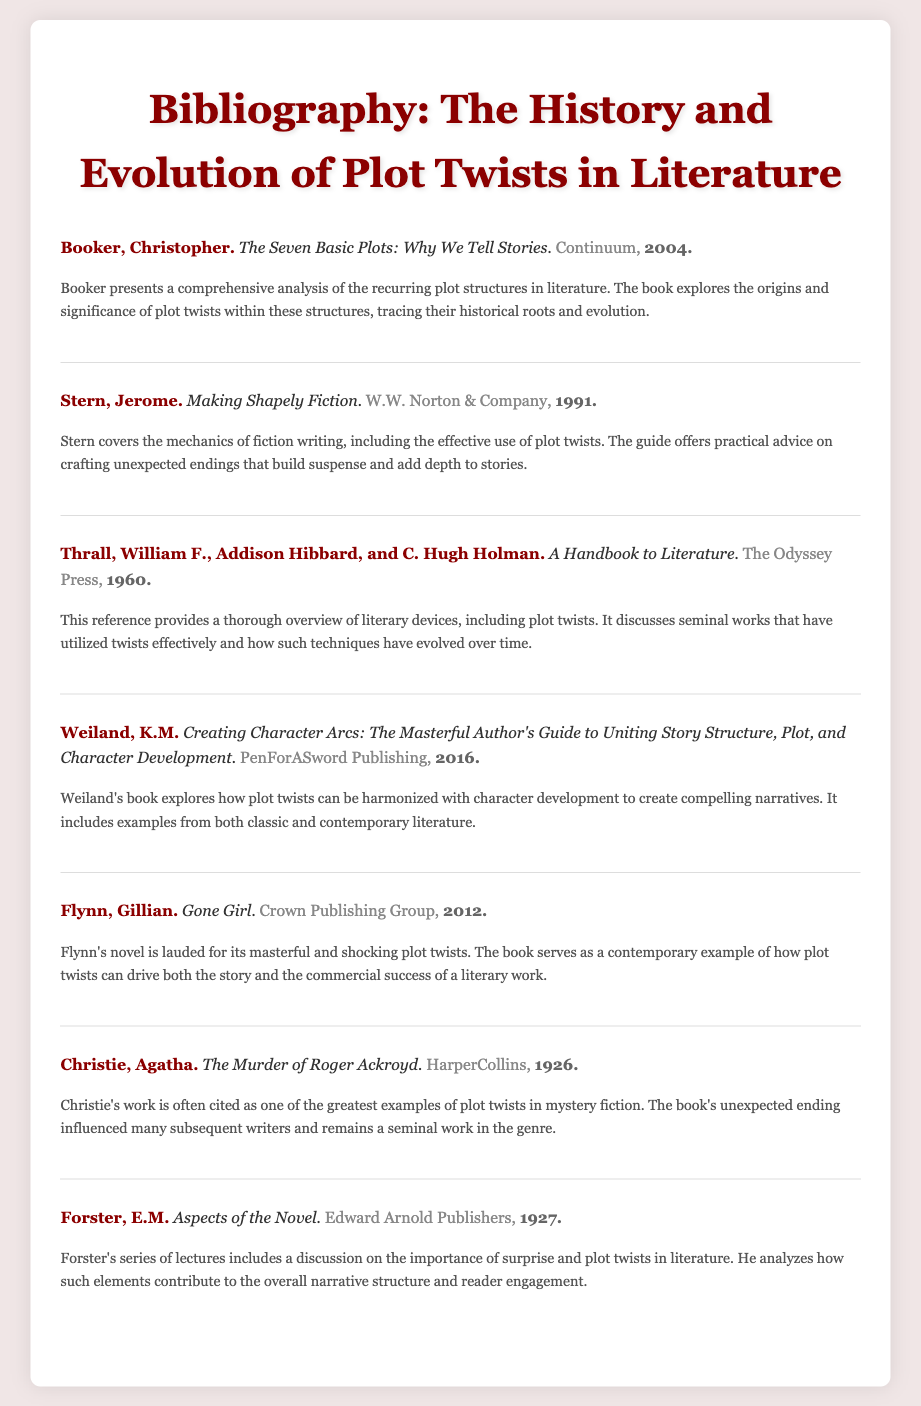What is the title of Christopher Booker's book? The title of Booker's book is directly mentioned in the entry, which is "The Seven Basic Plots: Why We Tell Stories."
Answer: The Seven Basic Plots: Why We Tell Stories Who is the author of "Gone Girl"? The author is explicitly stated in the entry for "Gone Girl," which lists Gillian Flynn as the author.
Answer: Gillian Flynn What year was "The Murder of Roger Ackroyd" published? The publication year is specified in the entry for "The Murder of Roger Ackroyd," which indicates it was published in 1926.
Answer: 1926 Which publisher published "Creating Character Arcs"? The publisher is mentioned in the entry for "Creating Character Arcs," which states PenForASword Publishing as the publisher.
Answer: PenForASword Publishing What literary device is discussed in "A Handbook to Literature"? The document includes a description that specifies plot twists as one of the literary devices discussed in the handbook.
Answer: Plot twists Which author discusses the importance of surprise in literature? The entry for E.M. Forster's book indicates that he discusses the importance of surprise and plot twists.
Answer: E.M. Forster What notable technique does Jerome Stern provide advice on? The entry for Jerome Stern indicates that he covers the effective use of plot twists, which is a notable technique in fiction writing.
Answer: Plot twists Which work is cited as a seminal example in mystery fiction? The entry for Agatha Christie's book clarifies that "The Murder of Roger Ackroyd" is often cited as a great example in mystery fiction.
Answer: The Murder of Roger Ackroyd 